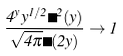Convert formula to latex. <formula><loc_0><loc_0><loc_500><loc_500>\frac { 4 ^ { y } y ^ { 1 / 2 } \Gamma ^ { 2 } ( y ) } { \sqrt { 4 \pi } \Gamma ( 2 y ) } \to 1</formula> 